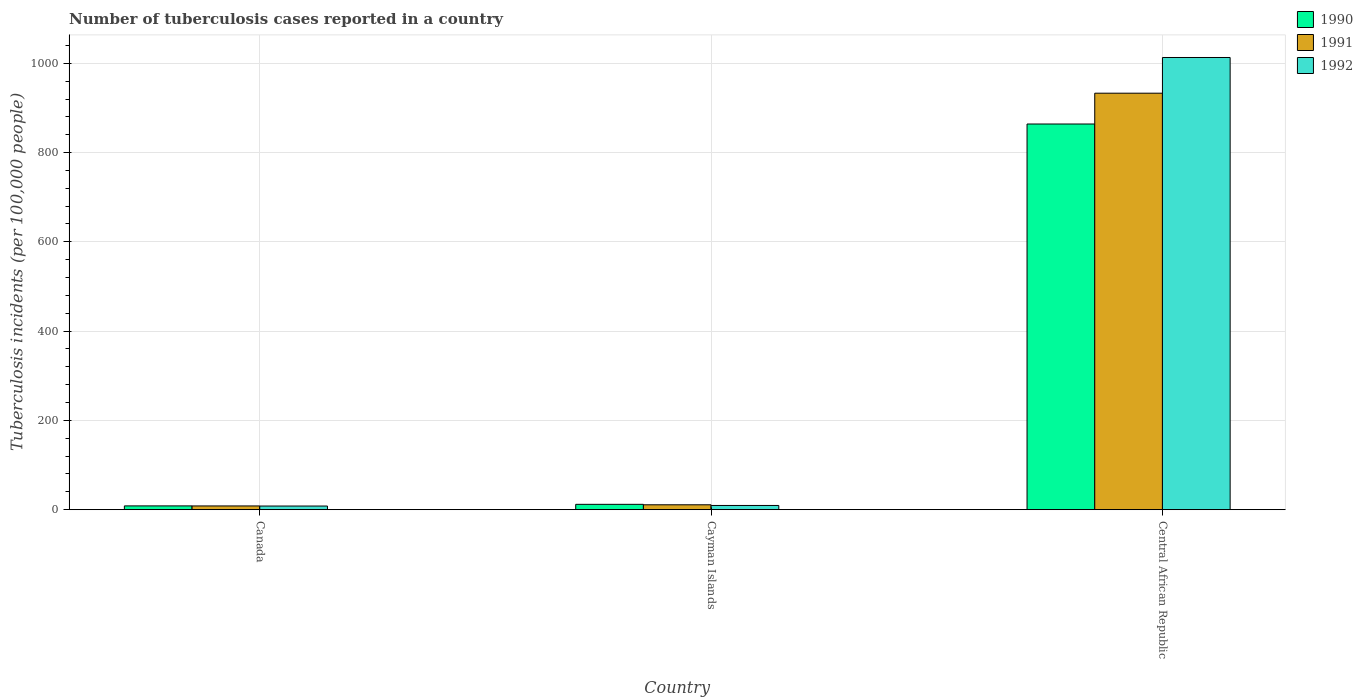What is the label of the 1st group of bars from the left?
Your response must be concise. Canada. What is the number of tuberculosis cases reported in in 1990 in Central African Republic?
Provide a short and direct response. 864. Across all countries, what is the maximum number of tuberculosis cases reported in in 1991?
Your answer should be compact. 933. In which country was the number of tuberculosis cases reported in in 1992 maximum?
Offer a terse response. Central African Republic. In which country was the number of tuberculosis cases reported in in 1992 minimum?
Your response must be concise. Canada. What is the total number of tuberculosis cases reported in in 1991 in the graph?
Your answer should be compact. 952.4. What is the difference between the number of tuberculosis cases reported in in 1990 in Canada and that in Central African Republic?
Keep it short and to the point. -855.5. What is the difference between the number of tuberculosis cases reported in in 1992 in Cayman Islands and the number of tuberculosis cases reported in in 1991 in Central African Republic?
Make the answer very short. -923.5. What is the average number of tuberculosis cases reported in in 1992 per country?
Give a very brief answer. 343.57. What is the ratio of the number of tuberculosis cases reported in in 1992 in Cayman Islands to that in Central African Republic?
Give a very brief answer. 0.01. Is the number of tuberculosis cases reported in in 1992 in Canada less than that in Central African Republic?
Offer a very short reply. Yes. Is the difference between the number of tuberculosis cases reported in in 1992 in Cayman Islands and Central African Republic greater than the difference between the number of tuberculosis cases reported in in 1990 in Cayman Islands and Central African Republic?
Provide a short and direct response. No. What is the difference between the highest and the second highest number of tuberculosis cases reported in in 1991?
Your answer should be very brief. -2.6. What is the difference between the highest and the lowest number of tuberculosis cases reported in in 1992?
Ensure brevity in your answer.  1004.8. Is the sum of the number of tuberculosis cases reported in in 1990 in Canada and Central African Republic greater than the maximum number of tuberculosis cases reported in in 1992 across all countries?
Offer a terse response. No. What does the 2nd bar from the right in Cayman Islands represents?
Keep it short and to the point. 1991. Is it the case that in every country, the sum of the number of tuberculosis cases reported in in 1990 and number of tuberculosis cases reported in in 1992 is greater than the number of tuberculosis cases reported in in 1991?
Provide a succinct answer. Yes. Are all the bars in the graph horizontal?
Your answer should be compact. No. How many countries are there in the graph?
Ensure brevity in your answer.  3. What is the difference between two consecutive major ticks on the Y-axis?
Your answer should be compact. 200. Where does the legend appear in the graph?
Make the answer very short. Top right. What is the title of the graph?
Give a very brief answer. Number of tuberculosis cases reported in a country. Does "1992" appear as one of the legend labels in the graph?
Offer a terse response. Yes. What is the label or title of the X-axis?
Give a very brief answer. Country. What is the label or title of the Y-axis?
Offer a very short reply. Tuberculosis incidents (per 100,0 people). What is the Tuberculosis incidents (per 100,000 people) in 1991 in Canada?
Offer a terse response. 8.4. What is the Tuberculosis incidents (per 100,000 people) of 1992 in Canada?
Give a very brief answer. 8.2. What is the Tuberculosis incidents (per 100,000 people) of 1992 in Cayman Islands?
Your response must be concise. 9.5. What is the Tuberculosis incidents (per 100,000 people) of 1990 in Central African Republic?
Ensure brevity in your answer.  864. What is the Tuberculosis incidents (per 100,000 people) in 1991 in Central African Republic?
Give a very brief answer. 933. What is the Tuberculosis incidents (per 100,000 people) in 1992 in Central African Republic?
Your answer should be very brief. 1013. Across all countries, what is the maximum Tuberculosis incidents (per 100,000 people) in 1990?
Offer a terse response. 864. Across all countries, what is the maximum Tuberculosis incidents (per 100,000 people) in 1991?
Your response must be concise. 933. Across all countries, what is the maximum Tuberculosis incidents (per 100,000 people) of 1992?
Provide a short and direct response. 1013. Across all countries, what is the minimum Tuberculosis incidents (per 100,000 people) of 1990?
Your answer should be very brief. 8.5. Across all countries, what is the minimum Tuberculosis incidents (per 100,000 people) in 1991?
Your answer should be very brief. 8.4. Across all countries, what is the minimum Tuberculosis incidents (per 100,000 people) in 1992?
Your answer should be compact. 8.2. What is the total Tuberculosis incidents (per 100,000 people) of 1990 in the graph?
Keep it short and to the point. 884.5. What is the total Tuberculosis incidents (per 100,000 people) of 1991 in the graph?
Ensure brevity in your answer.  952.4. What is the total Tuberculosis incidents (per 100,000 people) in 1992 in the graph?
Give a very brief answer. 1030.7. What is the difference between the Tuberculosis incidents (per 100,000 people) in 1991 in Canada and that in Cayman Islands?
Your answer should be compact. -2.6. What is the difference between the Tuberculosis incidents (per 100,000 people) in 1990 in Canada and that in Central African Republic?
Your response must be concise. -855.5. What is the difference between the Tuberculosis incidents (per 100,000 people) of 1991 in Canada and that in Central African Republic?
Keep it short and to the point. -924.6. What is the difference between the Tuberculosis incidents (per 100,000 people) of 1992 in Canada and that in Central African Republic?
Ensure brevity in your answer.  -1004.8. What is the difference between the Tuberculosis incidents (per 100,000 people) in 1990 in Cayman Islands and that in Central African Republic?
Ensure brevity in your answer.  -852. What is the difference between the Tuberculosis incidents (per 100,000 people) of 1991 in Cayman Islands and that in Central African Republic?
Ensure brevity in your answer.  -922. What is the difference between the Tuberculosis incidents (per 100,000 people) in 1992 in Cayman Islands and that in Central African Republic?
Make the answer very short. -1003.5. What is the difference between the Tuberculosis incidents (per 100,000 people) in 1990 in Canada and the Tuberculosis incidents (per 100,000 people) in 1991 in Cayman Islands?
Make the answer very short. -2.5. What is the difference between the Tuberculosis incidents (per 100,000 people) in 1990 in Canada and the Tuberculosis incidents (per 100,000 people) in 1992 in Cayman Islands?
Your answer should be compact. -1. What is the difference between the Tuberculosis incidents (per 100,000 people) of 1990 in Canada and the Tuberculosis incidents (per 100,000 people) of 1991 in Central African Republic?
Ensure brevity in your answer.  -924.5. What is the difference between the Tuberculosis incidents (per 100,000 people) of 1990 in Canada and the Tuberculosis incidents (per 100,000 people) of 1992 in Central African Republic?
Your answer should be very brief. -1004.5. What is the difference between the Tuberculosis incidents (per 100,000 people) of 1991 in Canada and the Tuberculosis incidents (per 100,000 people) of 1992 in Central African Republic?
Offer a very short reply. -1004.6. What is the difference between the Tuberculosis incidents (per 100,000 people) of 1990 in Cayman Islands and the Tuberculosis incidents (per 100,000 people) of 1991 in Central African Republic?
Offer a terse response. -921. What is the difference between the Tuberculosis incidents (per 100,000 people) in 1990 in Cayman Islands and the Tuberculosis incidents (per 100,000 people) in 1992 in Central African Republic?
Give a very brief answer. -1001. What is the difference between the Tuberculosis incidents (per 100,000 people) in 1991 in Cayman Islands and the Tuberculosis incidents (per 100,000 people) in 1992 in Central African Republic?
Make the answer very short. -1002. What is the average Tuberculosis incidents (per 100,000 people) of 1990 per country?
Provide a short and direct response. 294.83. What is the average Tuberculosis incidents (per 100,000 people) in 1991 per country?
Your answer should be compact. 317.47. What is the average Tuberculosis incidents (per 100,000 people) in 1992 per country?
Give a very brief answer. 343.57. What is the difference between the Tuberculosis incidents (per 100,000 people) in 1990 and Tuberculosis incidents (per 100,000 people) in 1992 in Canada?
Provide a succinct answer. 0.3. What is the difference between the Tuberculosis incidents (per 100,000 people) of 1990 and Tuberculosis incidents (per 100,000 people) of 1991 in Cayman Islands?
Provide a succinct answer. 1. What is the difference between the Tuberculosis incidents (per 100,000 people) of 1991 and Tuberculosis incidents (per 100,000 people) of 1992 in Cayman Islands?
Your response must be concise. 1.5. What is the difference between the Tuberculosis incidents (per 100,000 people) in 1990 and Tuberculosis incidents (per 100,000 people) in 1991 in Central African Republic?
Offer a very short reply. -69. What is the difference between the Tuberculosis incidents (per 100,000 people) of 1990 and Tuberculosis incidents (per 100,000 people) of 1992 in Central African Republic?
Offer a very short reply. -149. What is the difference between the Tuberculosis incidents (per 100,000 people) of 1991 and Tuberculosis incidents (per 100,000 people) of 1992 in Central African Republic?
Make the answer very short. -80. What is the ratio of the Tuberculosis incidents (per 100,000 people) of 1990 in Canada to that in Cayman Islands?
Keep it short and to the point. 0.71. What is the ratio of the Tuberculosis incidents (per 100,000 people) of 1991 in Canada to that in Cayman Islands?
Provide a succinct answer. 0.76. What is the ratio of the Tuberculosis incidents (per 100,000 people) in 1992 in Canada to that in Cayman Islands?
Offer a terse response. 0.86. What is the ratio of the Tuberculosis incidents (per 100,000 people) in 1990 in Canada to that in Central African Republic?
Your response must be concise. 0.01. What is the ratio of the Tuberculosis incidents (per 100,000 people) of 1991 in Canada to that in Central African Republic?
Your response must be concise. 0.01. What is the ratio of the Tuberculosis incidents (per 100,000 people) of 1992 in Canada to that in Central African Republic?
Your answer should be very brief. 0.01. What is the ratio of the Tuberculosis incidents (per 100,000 people) of 1990 in Cayman Islands to that in Central African Republic?
Offer a very short reply. 0.01. What is the ratio of the Tuberculosis incidents (per 100,000 people) of 1991 in Cayman Islands to that in Central African Republic?
Provide a succinct answer. 0.01. What is the ratio of the Tuberculosis incidents (per 100,000 people) in 1992 in Cayman Islands to that in Central African Republic?
Your answer should be compact. 0.01. What is the difference between the highest and the second highest Tuberculosis incidents (per 100,000 people) of 1990?
Give a very brief answer. 852. What is the difference between the highest and the second highest Tuberculosis incidents (per 100,000 people) of 1991?
Your answer should be very brief. 922. What is the difference between the highest and the second highest Tuberculosis incidents (per 100,000 people) of 1992?
Your response must be concise. 1003.5. What is the difference between the highest and the lowest Tuberculosis incidents (per 100,000 people) in 1990?
Ensure brevity in your answer.  855.5. What is the difference between the highest and the lowest Tuberculosis incidents (per 100,000 people) in 1991?
Your response must be concise. 924.6. What is the difference between the highest and the lowest Tuberculosis incidents (per 100,000 people) in 1992?
Your answer should be compact. 1004.8. 